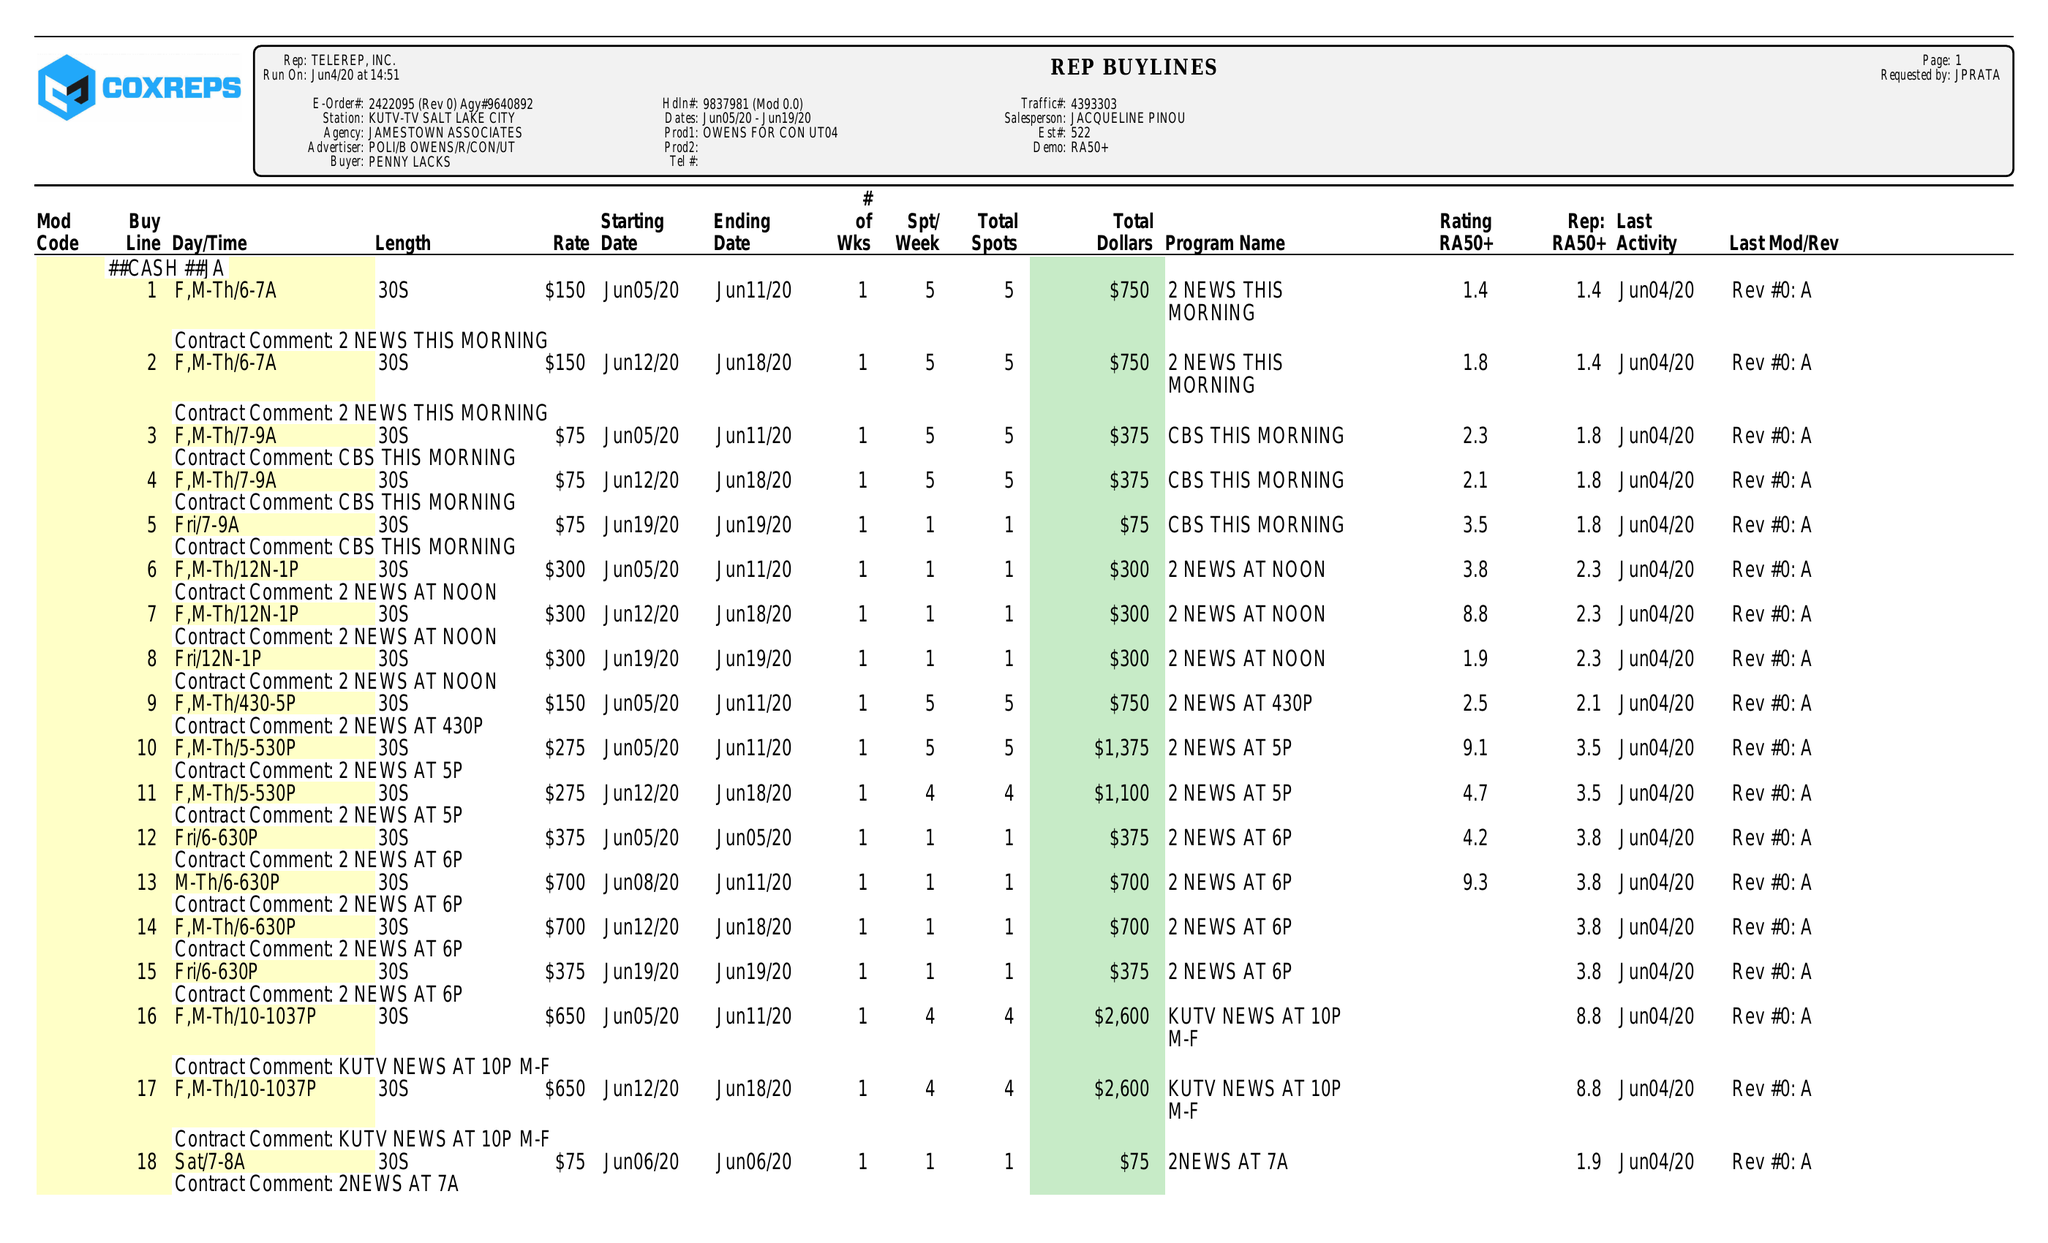What is the value for the flight_from?
Answer the question using a single word or phrase. 06/05/20 